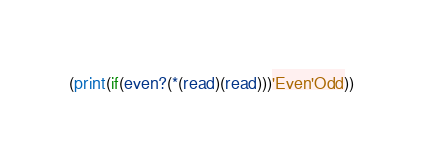Convert code to text. <code><loc_0><loc_0><loc_500><loc_500><_Scheme_>(print(if(even?(*(read)(read)))'Even'Odd))</code> 